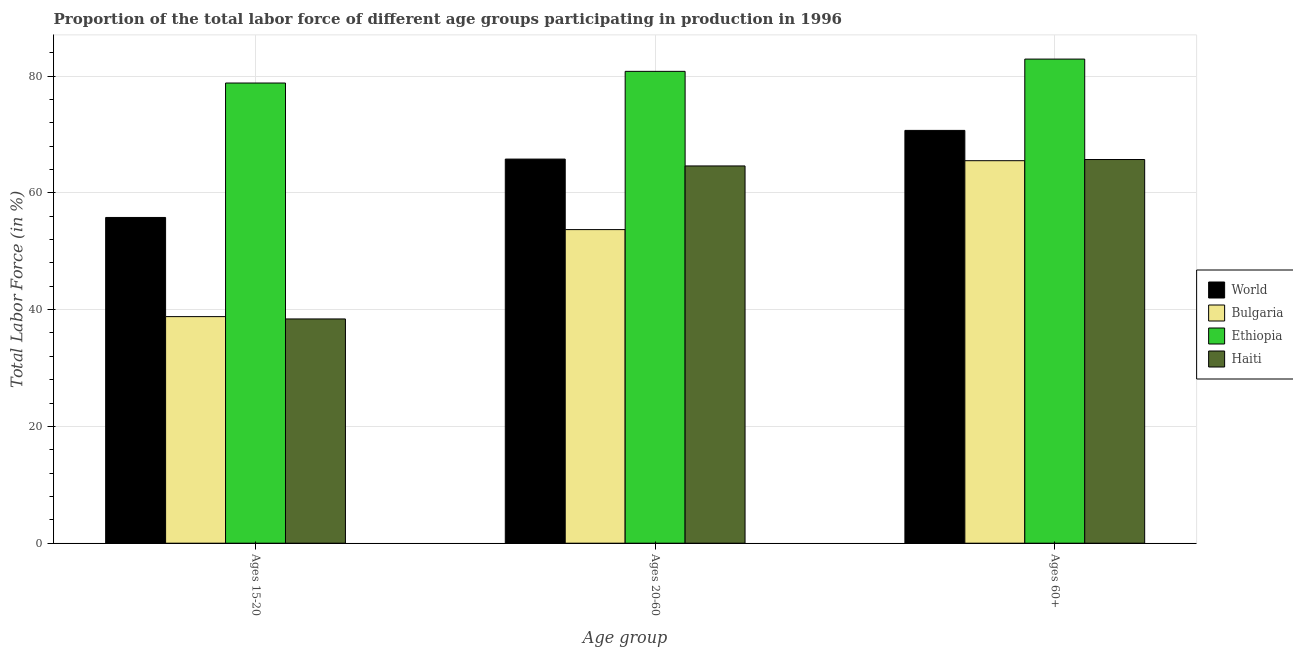How many different coloured bars are there?
Keep it short and to the point. 4. How many groups of bars are there?
Give a very brief answer. 3. Are the number of bars on each tick of the X-axis equal?
Provide a short and direct response. Yes. What is the label of the 2nd group of bars from the left?
Give a very brief answer. Ages 20-60. What is the percentage of labor force within the age group 20-60 in World?
Your answer should be very brief. 65.78. Across all countries, what is the maximum percentage of labor force above age 60?
Your response must be concise. 82.9. Across all countries, what is the minimum percentage of labor force above age 60?
Give a very brief answer. 65.5. In which country was the percentage of labor force within the age group 20-60 maximum?
Offer a terse response. Ethiopia. In which country was the percentage of labor force within the age group 15-20 minimum?
Ensure brevity in your answer.  Haiti. What is the total percentage of labor force within the age group 15-20 in the graph?
Provide a succinct answer. 211.78. What is the difference between the percentage of labor force above age 60 in Bulgaria and that in Haiti?
Your response must be concise. -0.2. What is the difference between the percentage of labor force within the age group 15-20 in Haiti and the percentage of labor force above age 60 in World?
Keep it short and to the point. -32.29. What is the average percentage of labor force within the age group 20-60 per country?
Offer a terse response. 66.22. What is the difference between the percentage of labor force within the age group 15-20 and percentage of labor force within the age group 20-60 in World?
Your answer should be very brief. -10. In how many countries, is the percentage of labor force within the age group 20-60 greater than 12 %?
Your answer should be very brief. 4. What is the ratio of the percentage of labor force within the age group 15-20 in Bulgaria to that in Haiti?
Ensure brevity in your answer.  1.01. What is the difference between the highest and the second highest percentage of labor force within the age group 15-20?
Provide a succinct answer. 23.02. What is the difference between the highest and the lowest percentage of labor force above age 60?
Your response must be concise. 17.4. What does the 3rd bar from the left in Ages 15-20 represents?
Give a very brief answer. Ethiopia. What does the 1st bar from the right in Ages 15-20 represents?
Keep it short and to the point. Haiti. How many bars are there?
Offer a terse response. 12. Are all the bars in the graph horizontal?
Your answer should be very brief. No. How many countries are there in the graph?
Make the answer very short. 4. Are the values on the major ticks of Y-axis written in scientific E-notation?
Provide a short and direct response. No. Does the graph contain any zero values?
Ensure brevity in your answer.  No. Does the graph contain grids?
Your answer should be compact. Yes. Where does the legend appear in the graph?
Your answer should be compact. Center right. How many legend labels are there?
Give a very brief answer. 4. How are the legend labels stacked?
Your response must be concise. Vertical. What is the title of the graph?
Your answer should be compact. Proportion of the total labor force of different age groups participating in production in 1996. What is the label or title of the X-axis?
Provide a short and direct response. Age group. What is the label or title of the Y-axis?
Offer a very short reply. Total Labor Force (in %). What is the Total Labor Force (in %) in World in Ages 15-20?
Make the answer very short. 55.78. What is the Total Labor Force (in %) in Bulgaria in Ages 15-20?
Provide a succinct answer. 38.8. What is the Total Labor Force (in %) in Ethiopia in Ages 15-20?
Offer a terse response. 78.8. What is the Total Labor Force (in %) in Haiti in Ages 15-20?
Provide a short and direct response. 38.4. What is the Total Labor Force (in %) in World in Ages 20-60?
Your answer should be very brief. 65.78. What is the Total Labor Force (in %) of Bulgaria in Ages 20-60?
Offer a very short reply. 53.7. What is the Total Labor Force (in %) in Ethiopia in Ages 20-60?
Ensure brevity in your answer.  80.8. What is the Total Labor Force (in %) of Haiti in Ages 20-60?
Keep it short and to the point. 64.6. What is the Total Labor Force (in %) in World in Ages 60+?
Your response must be concise. 70.69. What is the Total Labor Force (in %) of Bulgaria in Ages 60+?
Your response must be concise. 65.5. What is the Total Labor Force (in %) in Ethiopia in Ages 60+?
Ensure brevity in your answer.  82.9. What is the Total Labor Force (in %) in Haiti in Ages 60+?
Offer a terse response. 65.7. Across all Age group, what is the maximum Total Labor Force (in %) in World?
Your response must be concise. 70.69. Across all Age group, what is the maximum Total Labor Force (in %) in Bulgaria?
Give a very brief answer. 65.5. Across all Age group, what is the maximum Total Labor Force (in %) of Ethiopia?
Provide a succinct answer. 82.9. Across all Age group, what is the maximum Total Labor Force (in %) in Haiti?
Offer a very short reply. 65.7. Across all Age group, what is the minimum Total Labor Force (in %) of World?
Keep it short and to the point. 55.78. Across all Age group, what is the minimum Total Labor Force (in %) of Bulgaria?
Make the answer very short. 38.8. Across all Age group, what is the minimum Total Labor Force (in %) in Ethiopia?
Offer a terse response. 78.8. Across all Age group, what is the minimum Total Labor Force (in %) of Haiti?
Ensure brevity in your answer.  38.4. What is the total Total Labor Force (in %) of World in the graph?
Your response must be concise. 192.24. What is the total Total Labor Force (in %) in Bulgaria in the graph?
Provide a short and direct response. 158. What is the total Total Labor Force (in %) of Ethiopia in the graph?
Give a very brief answer. 242.5. What is the total Total Labor Force (in %) in Haiti in the graph?
Give a very brief answer. 168.7. What is the difference between the Total Labor Force (in %) of World in Ages 15-20 and that in Ages 20-60?
Your answer should be very brief. -10. What is the difference between the Total Labor Force (in %) in Bulgaria in Ages 15-20 and that in Ages 20-60?
Make the answer very short. -14.9. What is the difference between the Total Labor Force (in %) in Haiti in Ages 15-20 and that in Ages 20-60?
Provide a succinct answer. -26.2. What is the difference between the Total Labor Force (in %) of World in Ages 15-20 and that in Ages 60+?
Provide a short and direct response. -14.91. What is the difference between the Total Labor Force (in %) of Bulgaria in Ages 15-20 and that in Ages 60+?
Your answer should be very brief. -26.7. What is the difference between the Total Labor Force (in %) of Haiti in Ages 15-20 and that in Ages 60+?
Give a very brief answer. -27.3. What is the difference between the Total Labor Force (in %) in World in Ages 20-60 and that in Ages 60+?
Offer a terse response. -4.91. What is the difference between the Total Labor Force (in %) of Bulgaria in Ages 20-60 and that in Ages 60+?
Keep it short and to the point. -11.8. What is the difference between the Total Labor Force (in %) in World in Ages 15-20 and the Total Labor Force (in %) in Bulgaria in Ages 20-60?
Your answer should be compact. 2.08. What is the difference between the Total Labor Force (in %) of World in Ages 15-20 and the Total Labor Force (in %) of Ethiopia in Ages 20-60?
Provide a short and direct response. -25.02. What is the difference between the Total Labor Force (in %) of World in Ages 15-20 and the Total Labor Force (in %) of Haiti in Ages 20-60?
Provide a short and direct response. -8.82. What is the difference between the Total Labor Force (in %) of Bulgaria in Ages 15-20 and the Total Labor Force (in %) of Ethiopia in Ages 20-60?
Offer a very short reply. -42. What is the difference between the Total Labor Force (in %) in Bulgaria in Ages 15-20 and the Total Labor Force (in %) in Haiti in Ages 20-60?
Provide a short and direct response. -25.8. What is the difference between the Total Labor Force (in %) of World in Ages 15-20 and the Total Labor Force (in %) of Bulgaria in Ages 60+?
Give a very brief answer. -9.72. What is the difference between the Total Labor Force (in %) of World in Ages 15-20 and the Total Labor Force (in %) of Ethiopia in Ages 60+?
Offer a terse response. -27.12. What is the difference between the Total Labor Force (in %) of World in Ages 15-20 and the Total Labor Force (in %) of Haiti in Ages 60+?
Keep it short and to the point. -9.92. What is the difference between the Total Labor Force (in %) of Bulgaria in Ages 15-20 and the Total Labor Force (in %) of Ethiopia in Ages 60+?
Keep it short and to the point. -44.1. What is the difference between the Total Labor Force (in %) in Bulgaria in Ages 15-20 and the Total Labor Force (in %) in Haiti in Ages 60+?
Ensure brevity in your answer.  -26.9. What is the difference between the Total Labor Force (in %) of World in Ages 20-60 and the Total Labor Force (in %) of Bulgaria in Ages 60+?
Your response must be concise. 0.28. What is the difference between the Total Labor Force (in %) of World in Ages 20-60 and the Total Labor Force (in %) of Ethiopia in Ages 60+?
Provide a succinct answer. -17.12. What is the difference between the Total Labor Force (in %) in World in Ages 20-60 and the Total Labor Force (in %) in Haiti in Ages 60+?
Provide a short and direct response. 0.08. What is the difference between the Total Labor Force (in %) in Bulgaria in Ages 20-60 and the Total Labor Force (in %) in Ethiopia in Ages 60+?
Provide a succinct answer. -29.2. What is the difference between the Total Labor Force (in %) in Ethiopia in Ages 20-60 and the Total Labor Force (in %) in Haiti in Ages 60+?
Give a very brief answer. 15.1. What is the average Total Labor Force (in %) in World per Age group?
Provide a succinct answer. 64.08. What is the average Total Labor Force (in %) in Bulgaria per Age group?
Your response must be concise. 52.67. What is the average Total Labor Force (in %) in Ethiopia per Age group?
Your response must be concise. 80.83. What is the average Total Labor Force (in %) in Haiti per Age group?
Provide a succinct answer. 56.23. What is the difference between the Total Labor Force (in %) of World and Total Labor Force (in %) of Bulgaria in Ages 15-20?
Provide a short and direct response. 16.98. What is the difference between the Total Labor Force (in %) in World and Total Labor Force (in %) in Ethiopia in Ages 15-20?
Keep it short and to the point. -23.02. What is the difference between the Total Labor Force (in %) in World and Total Labor Force (in %) in Haiti in Ages 15-20?
Make the answer very short. 17.38. What is the difference between the Total Labor Force (in %) of Bulgaria and Total Labor Force (in %) of Ethiopia in Ages 15-20?
Offer a terse response. -40. What is the difference between the Total Labor Force (in %) of Bulgaria and Total Labor Force (in %) of Haiti in Ages 15-20?
Make the answer very short. 0.4. What is the difference between the Total Labor Force (in %) of Ethiopia and Total Labor Force (in %) of Haiti in Ages 15-20?
Provide a succinct answer. 40.4. What is the difference between the Total Labor Force (in %) in World and Total Labor Force (in %) in Bulgaria in Ages 20-60?
Keep it short and to the point. 12.08. What is the difference between the Total Labor Force (in %) of World and Total Labor Force (in %) of Ethiopia in Ages 20-60?
Give a very brief answer. -15.02. What is the difference between the Total Labor Force (in %) in World and Total Labor Force (in %) in Haiti in Ages 20-60?
Give a very brief answer. 1.18. What is the difference between the Total Labor Force (in %) in Bulgaria and Total Labor Force (in %) in Ethiopia in Ages 20-60?
Provide a succinct answer. -27.1. What is the difference between the Total Labor Force (in %) in Bulgaria and Total Labor Force (in %) in Haiti in Ages 20-60?
Offer a very short reply. -10.9. What is the difference between the Total Labor Force (in %) of World and Total Labor Force (in %) of Bulgaria in Ages 60+?
Offer a terse response. 5.19. What is the difference between the Total Labor Force (in %) in World and Total Labor Force (in %) in Ethiopia in Ages 60+?
Your answer should be compact. -12.21. What is the difference between the Total Labor Force (in %) of World and Total Labor Force (in %) of Haiti in Ages 60+?
Your response must be concise. 4.99. What is the difference between the Total Labor Force (in %) of Bulgaria and Total Labor Force (in %) of Ethiopia in Ages 60+?
Your answer should be compact. -17.4. What is the difference between the Total Labor Force (in %) of Bulgaria and Total Labor Force (in %) of Haiti in Ages 60+?
Your answer should be compact. -0.2. What is the ratio of the Total Labor Force (in %) in World in Ages 15-20 to that in Ages 20-60?
Give a very brief answer. 0.85. What is the ratio of the Total Labor Force (in %) of Bulgaria in Ages 15-20 to that in Ages 20-60?
Provide a succinct answer. 0.72. What is the ratio of the Total Labor Force (in %) of Ethiopia in Ages 15-20 to that in Ages 20-60?
Provide a succinct answer. 0.98. What is the ratio of the Total Labor Force (in %) of Haiti in Ages 15-20 to that in Ages 20-60?
Your answer should be very brief. 0.59. What is the ratio of the Total Labor Force (in %) of World in Ages 15-20 to that in Ages 60+?
Your response must be concise. 0.79. What is the ratio of the Total Labor Force (in %) in Bulgaria in Ages 15-20 to that in Ages 60+?
Provide a short and direct response. 0.59. What is the ratio of the Total Labor Force (in %) of Ethiopia in Ages 15-20 to that in Ages 60+?
Provide a succinct answer. 0.95. What is the ratio of the Total Labor Force (in %) of Haiti in Ages 15-20 to that in Ages 60+?
Give a very brief answer. 0.58. What is the ratio of the Total Labor Force (in %) of World in Ages 20-60 to that in Ages 60+?
Your response must be concise. 0.93. What is the ratio of the Total Labor Force (in %) of Bulgaria in Ages 20-60 to that in Ages 60+?
Offer a terse response. 0.82. What is the ratio of the Total Labor Force (in %) in Ethiopia in Ages 20-60 to that in Ages 60+?
Make the answer very short. 0.97. What is the ratio of the Total Labor Force (in %) in Haiti in Ages 20-60 to that in Ages 60+?
Offer a very short reply. 0.98. What is the difference between the highest and the second highest Total Labor Force (in %) of World?
Provide a succinct answer. 4.91. What is the difference between the highest and the second highest Total Labor Force (in %) in Bulgaria?
Your answer should be compact. 11.8. What is the difference between the highest and the lowest Total Labor Force (in %) of World?
Keep it short and to the point. 14.91. What is the difference between the highest and the lowest Total Labor Force (in %) in Bulgaria?
Provide a succinct answer. 26.7. What is the difference between the highest and the lowest Total Labor Force (in %) in Haiti?
Your answer should be compact. 27.3. 